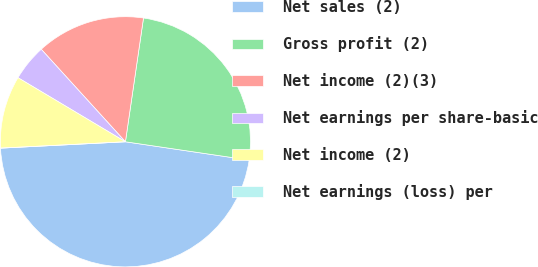Convert chart to OTSL. <chart><loc_0><loc_0><loc_500><loc_500><pie_chart><fcel>Net sales (2)<fcel>Gross profit (2)<fcel>Net income (2)(3)<fcel>Net earnings per share-basic<fcel>Net income (2)<fcel>Net earnings (loss) per<nl><fcel>46.86%<fcel>25.03%<fcel>14.06%<fcel>4.69%<fcel>9.37%<fcel>0.0%<nl></chart> 